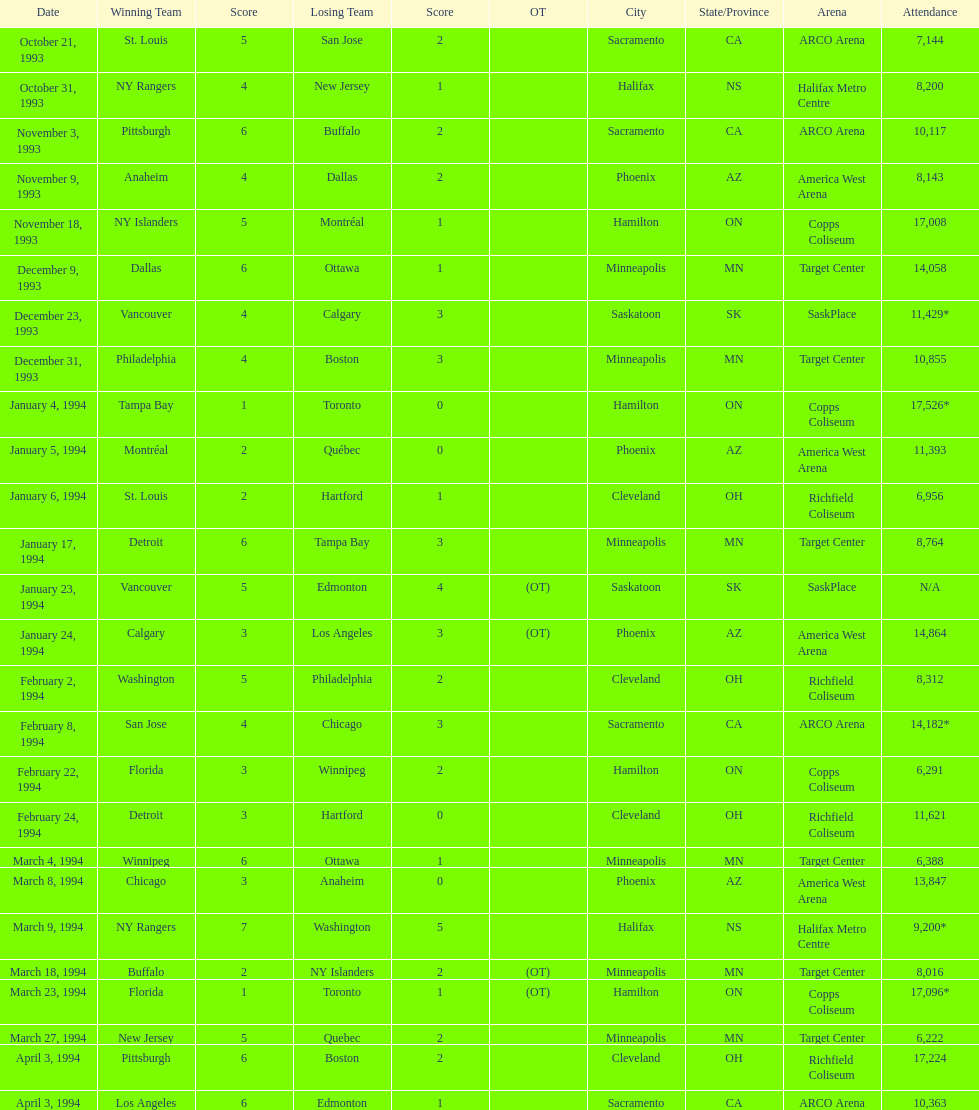On which days did all the games take place? October 21, 1993, October 31, 1993, November 3, 1993, November 9, 1993, November 18, 1993, December 9, 1993, December 23, 1993, December 31, 1993, January 4, 1994, January 5, 1994, January 6, 1994, January 17, 1994, January 23, 1994, January 24, 1994, February 2, 1994, February 8, 1994, February 22, 1994, February 24, 1994, March 4, 1994, March 8, 1994, March 9, 1994, March 18, 1994, March 23, 1994, March 27, 1994, April 3, 1994, April 3, 1994. What were the crowd sizes? 7,144, 8,200, 10,117, 8,143, 17,008, 14,058, 11,429*, 10,855, 17,526*, 11,393, 6,956, 8,764, N/A, 14,864, 8,312, 14,182*, 6,291, 11,621, 6,388, 13,847, 9,200*, 8,016, 17,096*, 6,222, 17,224, 10,363. From december 23, 1993, to january 24, 1994, which match had the most attendees? January 4, 1994. Write the full table. {'header': ['Date', 'Winning Team', 'Score', 'Losing Team', 'Score', 'OT', 'City', 'State/Province', 'Arena', 'Attendance'], 'rows': [['October 21, 1993', 'St. Louis', '5', 'San Jose', '2', '', 'Sacramento', 'CA', 'ARCO Arena', '7,144'], ['October 31, 1993', 'NY Rangers', '4', 'New Jersey', '1', '', 'Halifax', 'NS', 'Halifax Metro Centre', '8,200'], ['November 3, 1993', 'Pittsburgh', '6', 'Buffalo', '2', '', 'Sacramento', 'CA', 'ARCO Arena', '10,117'], ['November 9, 1993', 'Anaheim', '4', 'Dallas', '2', '', 'Phoenix', 'AZ', 'America West Arena', '8,143'], ['November 18, 1993', 'NY Islanders', '5', 'Montréal', '1', '', 'Hamilton', 'ON', 'Copps Coliseum', '17,008'], ['December 9, 1993', 'Dallas', '6', 'Ottawa', '1', '', 'Minneapolis', 'MN', 'Target Center', '14,058'], ['December 23, 1993', 'Vancouver', '4', 'Calgary', '3', '', 'Saskatoon', 'SK', 'SaskPlace', '11,429*'], ['December 31, 1993', 'Philadelphia', '4', 'Boston', '3', '', 'Minneapolis', 'MN', 'Target Center', '10,855'], ['January 4, 1994', 'Tampa Bay', '1', 'Toronto', '0', '', 'Hamilton', 'ON', 'Copps Coliseum', '17,526*'], ['January 5, 1994', 'Montréal', '2', 'Québec', '0', '', 'Phoenix', 'AZ', 'America West Arena', '11,393'], ['January 6, 1994', 'St. Louis', '2', 'Hartford', '1', '', 'Cleveland', 'OH', 'Richfield Coliseum', '6,956'], ['January 17, 1994', 'Detroit', '6', 'Tampa Bay', '3', '', 'Minneapolis', 'MN', 'Target Center', '8,764'], ['January 23, 1994', 'Vancouver', '5', 'Edmonton', '4', '(OT)', 'Saskatoon', 'SK', 'SaskPlace', 'N/A'], ['January 24, 1994', 'Calgary', '3', 'Los Angeles', '3', '(OT)', 'Phoenix', 'AZ', 'America West Arena', '14,864'], ['February 2, 1994', 'Washington', '5', 'Philadelphia', '2', '', 'Cleveland', 'OH', 'Richfield Coliseum', '8,312'], ['February 8, 1994', 'San Jose', '4', 'Chicago', '3', '', 'Sacramento', 'CA', 'ARCO Arena', '14,182*'], ['February 22, 1994', 'Florida', '3', 'Winnipeg', '2', '', 'Hamilton', 'ON', 'Copps Coliseum', '6,291'], ['February 24, 1994', 'Detroit', '3', 'Hartford', '0', '', 'Cleveland', 'OH', 'Richfield Coliseum', '11,621'], ['March 4, 1994', 'Winnipeg', '6', 'Ottawa', '1', '', 'Minneapolis', 'MN', 'Target Center', '6,388'], ['March 8, 1994', 'Chicago', '3', 'Anaheim', '0', '', 'Phoenix', 'AZ', 'America West Arena', '13,847'], ['March 9, 1994', 'NY Rangers', '7', 'Washington', '5', '', 'Halifax', 'NS', 'Halifax Metro Centre', '9,200*'], ['March 18, 1994', 'Buffalo', '2', 'NY Islanders', '2', '(OT)', 'Minneapolis', 'MN', 'Target Center', '8,016'], ['March 23, 1994', 'Florida', '1', 'Toronto', '1', '(OT)', 'Hamilton', 'ON', 'Copps Coliseum', '17,096*'], ['March 27, 1994', 'New Jersey', '5', 'Quebec', '2', '', 'Minneapolis', 'MN', 'Target Center', '6,222'], ['April 3, 1994', 'Pittsburgh', '6', 'Boston', '2', '', 'Cleveland', 'OH', 'Richfield Coliseum', '17,224'], ['April 3, 1994', 'Los Angeles', '6', 'Edmonton', '1', '', 'Sacramento', 'CA', 'ARCO Arena', '10,363']]} 